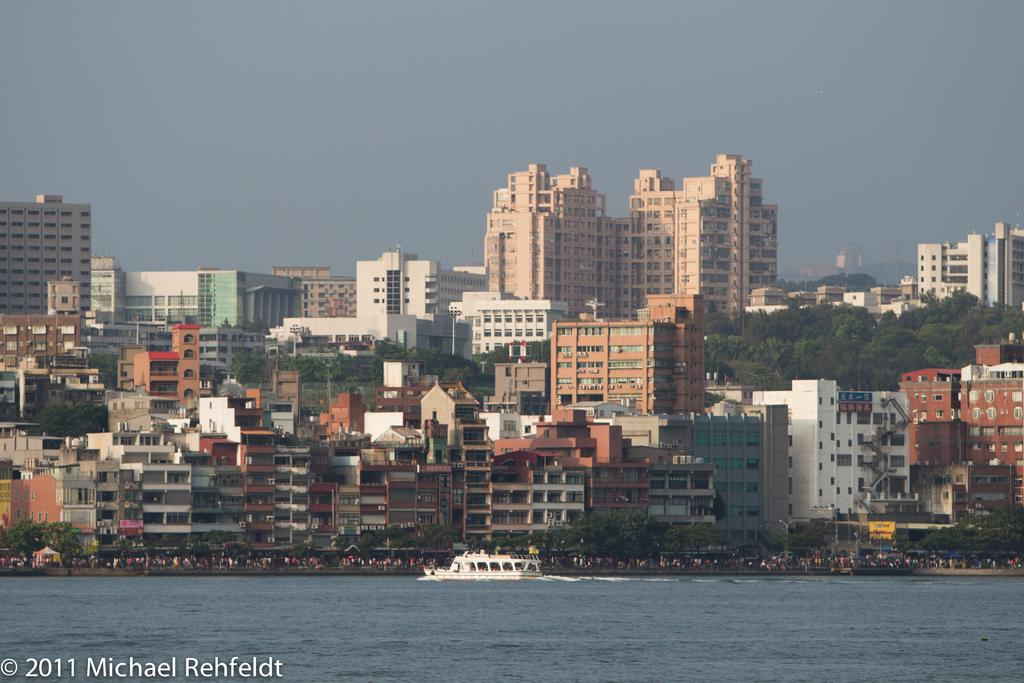What type of structures are present in the image? There are buildings with windows in the image. What natural element is visible in the image? There is water visible in the image. What is on the water in the image? There is a boat on the water. Who or what can be seen in the image? There are people visible in the image. What type of vegetation is present in the image? There are trees in the image. What part of the environment is visible in the image? The sky is visible in the image. Can you hear your aunt's voice in the image? There is no audio or sound present in the image, so it is not possible to hear any voices, including your aunt's. Is there a hose visible in the image? There is no mention of a hose in the provided facts, so it cannot be definitively stated that a hose is present in the image. 